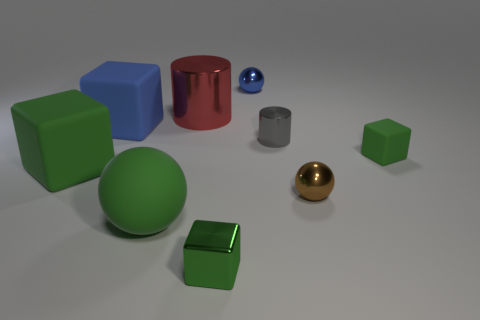Subtract all green cubes. How many were subtracted if there are1green cubes left? 2 Subtract all tiny brown spheres. How many spheres are left? 2 Subtract all red spheres. How many green cubes are left? 3 Subtract 1 cubes. How many cubes are left? 3 Add 1 cyan objects. How many objects exist? 10 Subtract all blue blocks. How many blocks are left? 3 Subtract all red balls. Subtract all yellow blocks. How many balls are left? 3 Add 2 brown spheres. How many brown spheres are left? 3 Add 7 big green rubber blocks. How many big green rubber blocks exist? 8 Subtract 0 brown cubes. How many objects are left? 9 